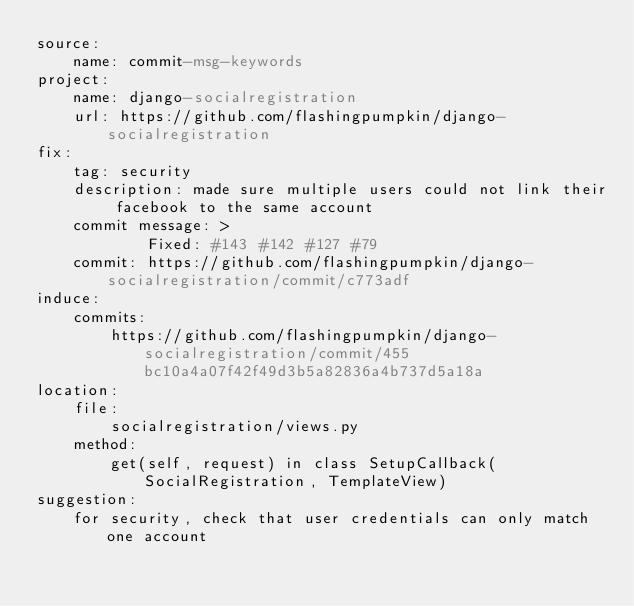Convert code to text. <code><loc_0><loc_0><loc_500><loc_500><_YAML_>source:
    name: commit-msg-keywords
project: 
    name: django-socialregistration
    url: https://github.com/flashingpumpkin/django-socialregistration
fix:
    tag: security
    description: made sure multiple users could not link their facebook to the same account
    commit message: >
            Fixed: #143 #142 #127 #79
    commit: https://github.com/flashingpumpkin/django-socialregistration/commit/c773adf
induce:
    commits:
        https://github.com/flashingpumpkin/django-socialregistration/commit/455bc10a4a07f42f49d3b5a82836a4b737d5a18a
location:
    file: 
        socialregistration/views.py
    method: 
        get(self, request) in class SetupCallback(SocialRegistration, TemplateView)
suggestion: 
    for security, check that user credentials can only match one account
</code> 